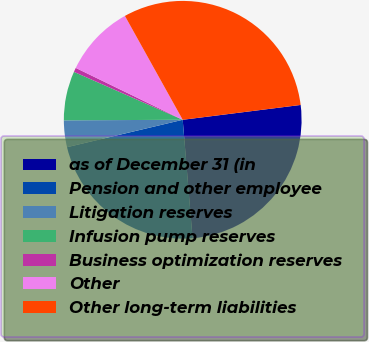<chart> <loc_0><loc_0><loc_500><loc_500><pie_chart><fcel>as of December 31 (in<fcel>Pension and other employee<fcel>Litigation reserves<fcel>Infusion pump reserves<fcel>Business optimization reserves<fcel>Other<fcel>Other long-term liabilities<nl><fcel>25.67%<fcel>22.62%<fcel>3.63%<fcel>6.68%<fcel>0.58%<fcel>9.73%<fcel>31.09%<nl></chart> 